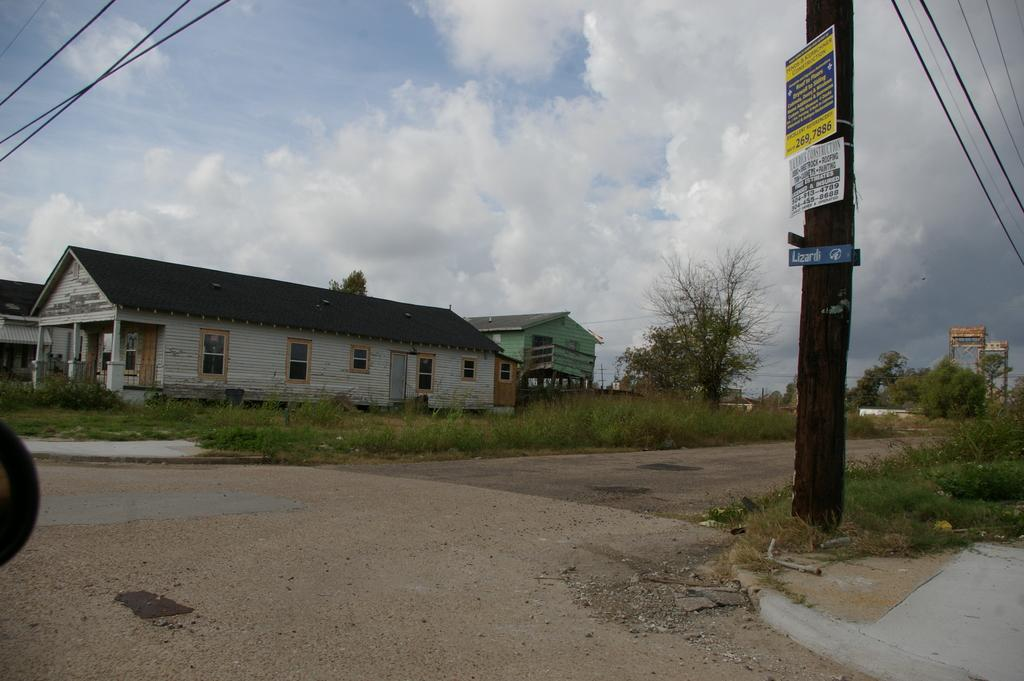What type of surface can be seen in the image? There is ground visible in the image. What is attached to the ground and has words on it? There is a huge pole with words on it in the image. What else is connected to the ground in the image? There are wires in the image. What type of vegetation is present in the image? There are green trees in the image. What type of structures can be seen in the image? There are buildings in the image. What can be seen in the background of the image? The sky is visible in the background of the image. How many beds can be seen in the image? There are no beds present in the image. What type of key is used to unlock the door of the building in the image? There is no door or key mentioned in the image; it only shows a pole, wires, trees, buildings, and the sky. 